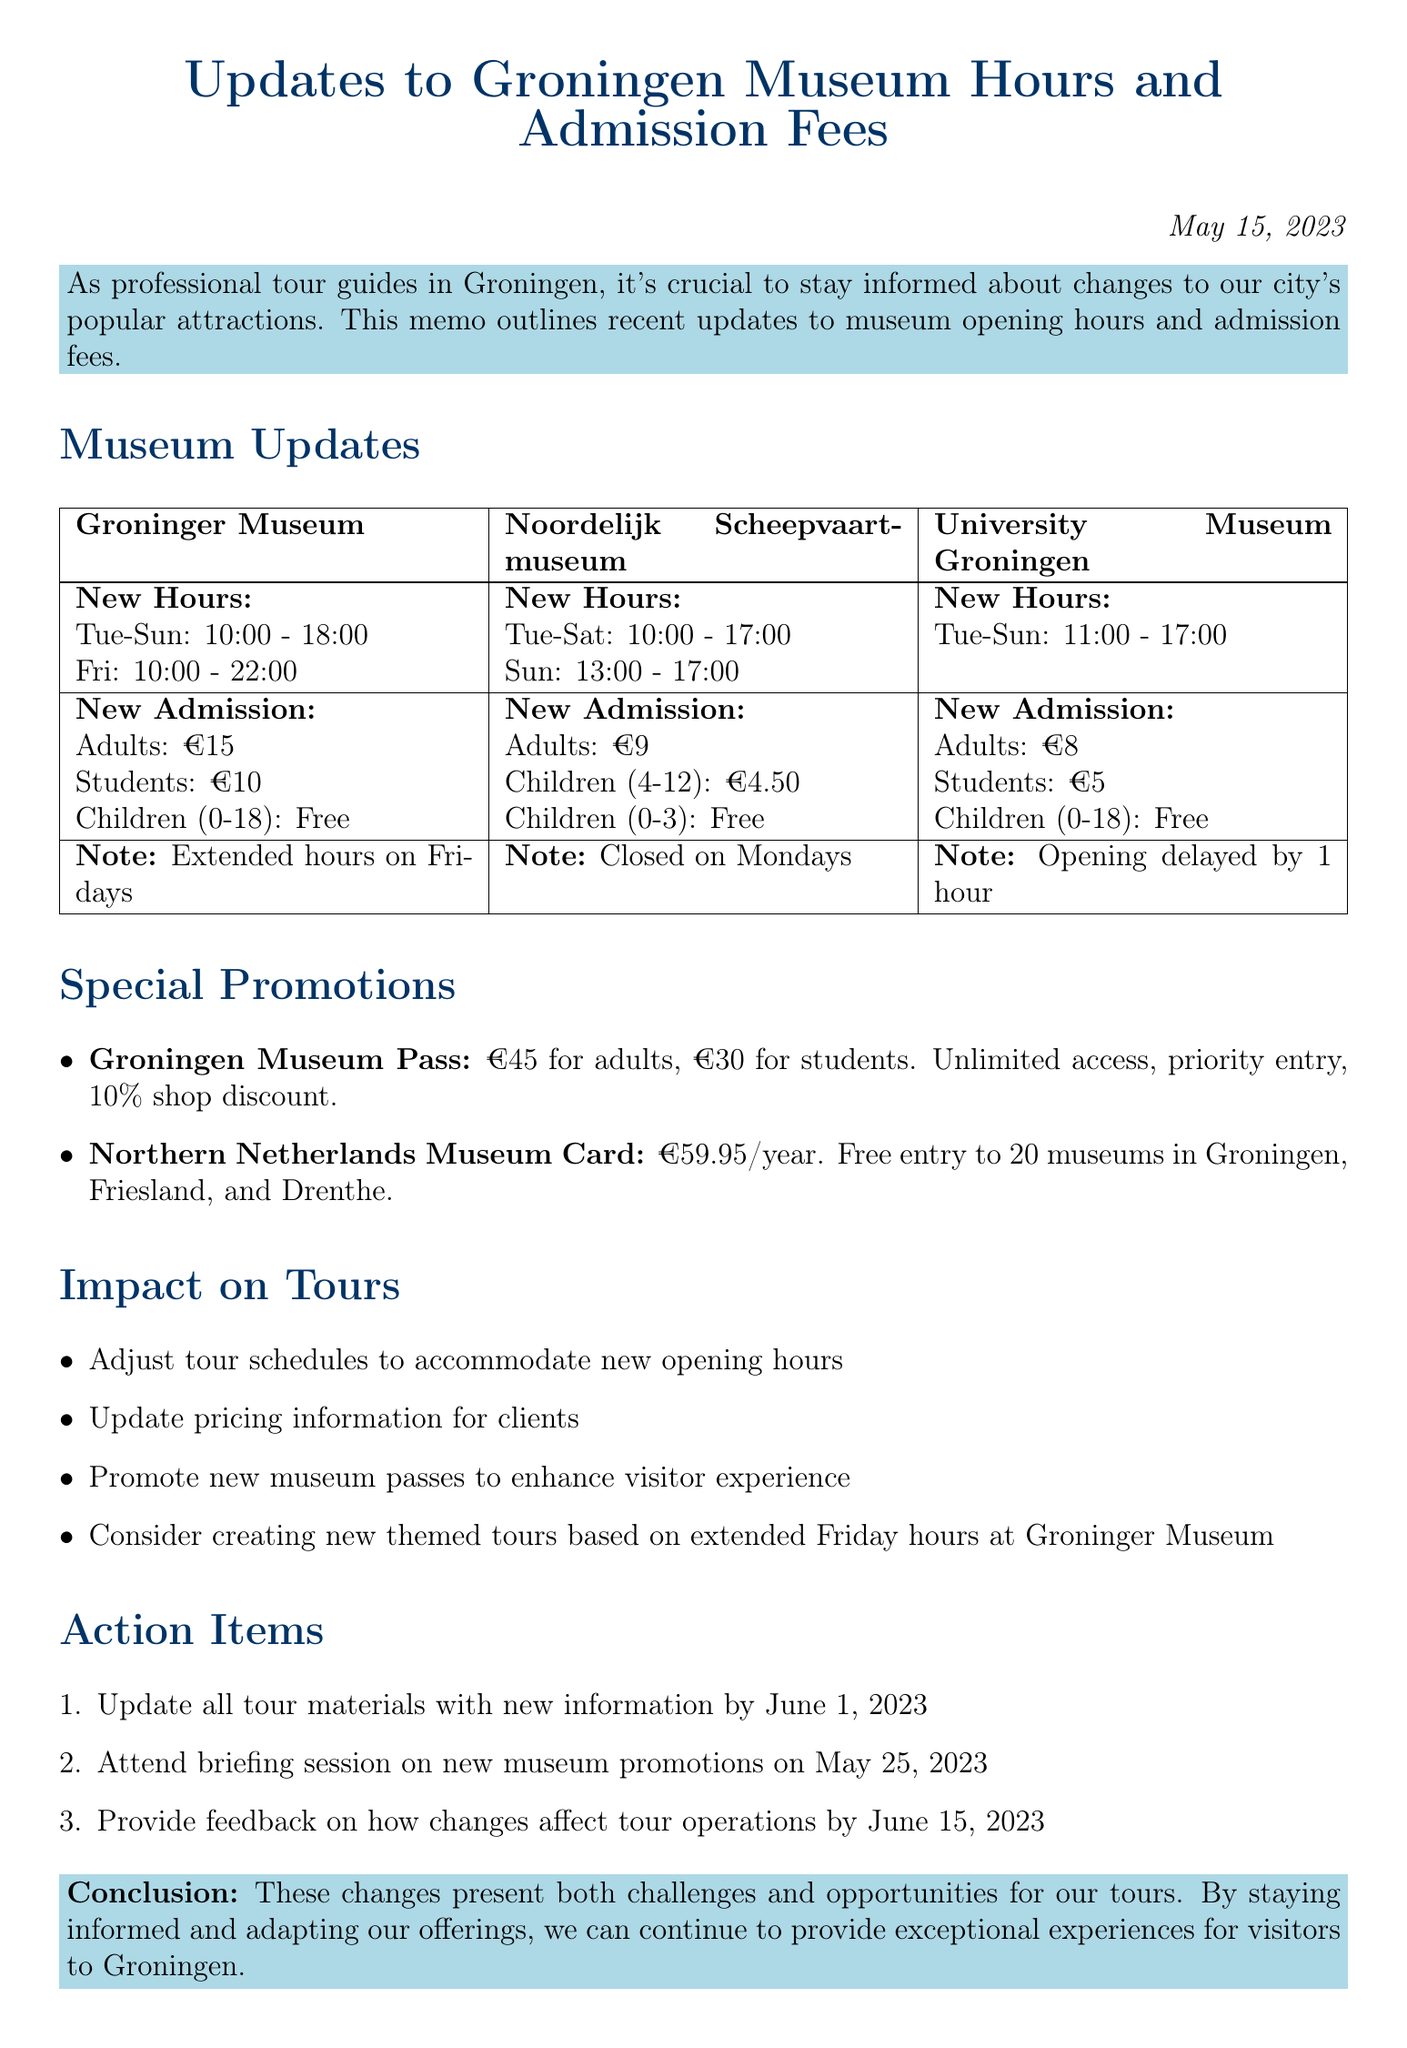What are the new opening hours for the Groninger Museum? The new opening hours for the Groninger Museum are Tuesday to Sunday: 10:00 - 18:00, Friday: 10:00 - 22:00.
Answer: Tuesday to Sunday: 10:00 - 18:00, Friday: 10:00 - 22:00 What is the new admission fee for adults at the Noordelijk Scheepvaartmuseum? The new admission fee for adults at the Noordelijk Scheepvaartmuseum is €9.
Answer: €9 How much does the Groningen Museum Pass cost for students? The price of the Groningen Museum Pass for students is mentioned in the memo.
Answer: €30 On which day is the Noordelijk Scheepvaartmuseum closed? It is explicitly stated in the document that the Noordelijk Scheepvaartmuseum is now closed on Mondays.
Answer: Mondays How will the changes in museum hours impact the tour schedules? The document mentions adjusting tour schedules to accommodate new opening hours, highlighting the need for coordination with the new times.
Answer: Adjust tour schedules What feedback deadline is specified for tour operations impacted by the changes? The memo indicates a specific date by which feedback should be provided regarding the changes.
Answer: June 15, 2023 What specific action is to be taken by June 1, 2023? The document outlines an important task that must be completed by a set date related to tour materials.
Answer: Update all tour materials What is one of the benefits of the Northern Netherlands Museum Card? The benefits listed for the Northern Netherlands Museum Card include features that enhance visitor experiences.
Answer: Free entry to all participating museums What conclusion does the memo highlight regarding the changes? The memo concludes by summarizing the overall impact of the changes on tours.
Answer: Challenges and opportunities 